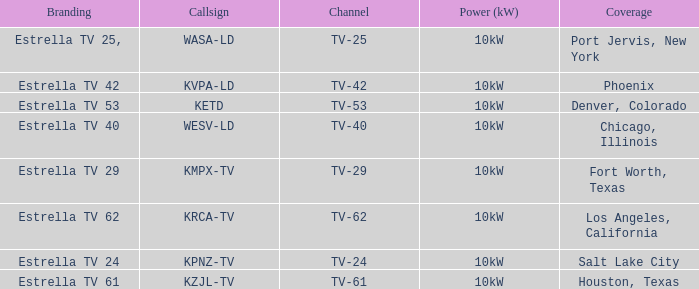Which city did kpnz-tv provide coverage for? Salt Lake City. 